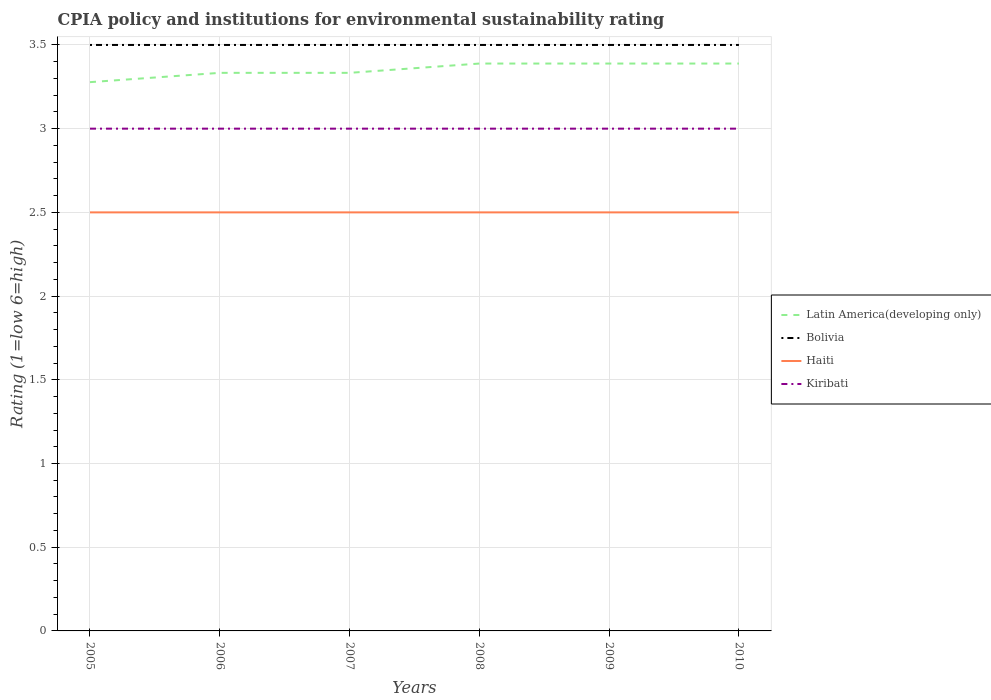Is the number of lines equal to the number of legend labels?
Keep it short and to the point. Yes. Across all years, what is the maximum CPIA rating in Latin America(developing only)?
Offer a terse response. 3.28. What is the total CPIA rating in Bolivia in the graph?
Keep it short and to the point. 0. What is the difference between the highest and the second highest CPIA rating in Latin America(developing only)?
Your answer should be very brief. 0.11. What is the difference between the highest and the lowest CPIA rating in Haiti?
Your answer should be very brief. 0. What is the difference between two consecutive major ticks on the Y-axis?
Offer a terse response. 0.5. Does the graph contain any zero values?
Give a very brief answer. No. Does the graph contain grids?
Ensure brevity in your answer.  Yes. How many legend labels are there?
Make the answer very short. 4. How are the legend labels stacked?
Give a very brief answer. Vertical. What is the title of the graph?
Ensure brevity in your answer.  CPIA policy and institutions for environmental sustainability rating. Does "Liberia" appear as one of the legend labels in the graph?
Offer a terse response. No. What is the label or title of the Y-axis?
Ensure brevity in your answer.  Rating (1=low 6=high). What is the Rating (1=low 6=high) of Latin America(developing only) in 2005?
Make the answer very short. 3.28. What is the Rating (1=low 6=high) of Latin America(developing only) in 2006?
Offer a terse response. 3.33. What is the Rating (1=low 6=high) of Latin America(developing only) in 2007?
Offer a terse response. 3.33. What is the Rating (1=low 6=high) in Haiti in 2007?
Offer a terse response. 2.5. What is the Rating (1=low 6=high) in Kiribati in 2007?
Make the answer very short. 3. What is the Rating (1=low 6=high) in Latin America(developing only) in 2008?
Ensure brevity in your answer.  3.39. What is the Rating (1=low 6=high) of Bolivia in 2008?
Your answer should be very brief. 3.5. What is the Rating (1=low 6=high) in Haiti in 2008?
Your answer should be very brief. 2.5. What is the Rating (1=low 6=high) in Kiribati in 2008?
Keep it short and to the point. 3. What is the Rating (1=low 6=high) of Latin America(developing only) in 2009?
Keep it short and to the point. 3.39. What is the Rating (1=low 6=high) in Latin America(developing only) in 2010?
Make the answer very short. 3.39. What is the Rating (1=low 6=high) of Bolivia in 2010?
Provide a short and direct response. 3.5. What is the Rating (1=low 6=high) of Haiti in 2010?
Give a very brief answer. 2.5. What is the Rating (1=low 6=high) in Kiribati in 2010?
Provide a short and direct response. 3. Across all years, what is the maximum Rating (1=low 6=high) of Latin America(developing only)?
Your answer should be compact. 3.39. Across all years, what is the maximum Rating (1=low 6=high) in Haiti?
Provide a succinct answer. 2.5. Across all years, what is the maximum Rating (1=low 6=high) in Kiribati?
Give a very brief answer. 3. Across all years, what is the minimum Rating (1=low 6=high) of Latin America(developing only)?
Your answer should be very brief. 3.28. What is the total Rating (1=low 6=high) in Latin America(developing only) in the graph?
Your answer should be very brief. 20.11. What is the total Rating (1=low 6=high) of Bolivia in the graph?
Offer a terse response. 21. What is the difference between the Rating (1=low 6=high) in Latin America(developing only) in 2005 and that in 2006?
Make the answer very short. -0.06. What is the difference between the Rating (1=low 6=high) in Bolivia in 2005 and that in 2006?
Provide a succinct answer. 0. What is the difference between the Rating (1=low 6=high) of Haiti in 2005 and that in 2006?
Make the answer very short. 0. What is the difference between the Rating (1=low 6=high) of Kiribati in 2005 and that in 2006?
Keep it short and to the point. 0. What is the difference between the Rating (1=low 6=high) of Latin America(developing only) in 2005 and that in 2007?
Make the answer very short. -0.06. What is the difference between the Rating (1=low 6=high) of Bolivia in 2005 and that in 2007?
Give a very brief answer. 0. What is the difference between the Rating (1=low 6=high) in Latin America(developing only) in 2005 and that in 2008?
Your answer should be very brief. -0.11. What is the difference between the Rating (1=low 6=high) of Bolivia in 2005 and that in 2008?
Provide a succinct answer. 0. What is the difference between the Rating (1=low 6=high) in Haiti in 2005 and that in 2008?
Offer a very short reply. 0. What is the difference between the Rating (1=low 6=high) of Latin America(developing only) in 2005 and that in 2009?
Your answer should be very brief. -0.11. What is the difference between the Rating (1=low 6=high) of Bolivia in 2005 and that in 2009?
Your response must be concise. 0. What is the difference between the Rating (1=low 6=high) of Kiribati in 2005 and that in 2009?
Provide a succinct answer. 0. What is the difference between the Rating (1=low 6=high) of Latin America(developing only) in 2005 and that in 2010?
Your answer should be compact. -0.11. What is the difference between the Rating (1=low 6=high) in Bolivia in 2005 and that in 2010?
Provide a short and direct response. 0. What is the difference between the Rating (1=low 6=high) of Kiribati in 2005 and that in 2010?
Give a very brief answer. 0. What is the difference between the Rating (1=low 6=high) in Latin America(developing only) in 2006 and that in 2007?
Make the answer very short. 0. What is the difference between the Rating (1=low 6=high) in Bolivia in 2006 and that in 2007?
Keep it short and to the point. 0. What is the difference between the Rating (1=low 6=high) of Haiti in 2006 and that in 2007?
Provide a succinct answer. 0. What is the difference between the Rating (1=low 6=high) of Kiribati in 2006 and that in 2007?
Make the answer very short. 0. What is the difference between the Rating (1=low 6=high) of Latin America(developing only) in 2006 and that in 2008?
Offer a terse response. -0.06. What is the difference between the Rating (1=low 6=high) in Latin America(developing only) in 2006 and that in 2009?
Provide a succinct answer. -0.06. What is the difference between the Rating (1=low 6=high) in Haiti in 2006 and that in 2009?
Your response must be concise. 0. What is the difference between the Rating (1=low 6=high) in Latin America(developing only) in 2006 and that in 2010?
Ensure brevity in your answer.  -0.06. What is the difference between the Rating (1=low 6=high) in Kiribati in 2006 and that in 2010?
Keep it short and to the point. 0. What is the difference between the Rating (1=low 6=high) in Latin America(developing only) in 2007 and that in 2008?
Your response must be concise. -0.06. What is the difference between the Rating (1=low 6=high) in Bolivia in 2007 and that in 2008?
Ensure brevity in your answer.  0. What is the difference between the Rating (1=low 6=high) in Haiti in 2007 and that in 2008?
Your answer should be compact. 0. What is the difference between the Rating (1=low 6=high) of Kiribati in 2007 and that in 2008?
Offer a very short reply. 0. What is the difference between the Rating (1=low 6=high) in Latin America(developing only) in 2007 and that in 2009?
Make the answer very short. -0.06. What is the difference between the Rating (1=low 6=high) in Latin America(developing only) in 2007 and that in 2010?
Provide a succinct answer. -0.06. What is the difference between the Rating (1=low 6=high) in Bolivia in 2007 and that in 2010?
Your answer should be compact. 0. What is the difference between the Rating (1=low 6=high) in Kiribati in 2007 and that in 2010?
Provide a short and direct response. 0. What is the difference between the Rating (1=low 6=high) in Bolivia in 2008 and that in 2009?
Offer a very short reply. 0. What is the difference between the Rating (1=low 6=high) in Haiti in 2008 and that in 2009?
Ensure brevity in your answer.  0. What is the difference between the Rating (1=low 6=high) of Latin America(developing only) in 2008 and that in 2010?
Your response must be concise. 0. What is the difference between the Rating (1=low 6=high) of Latin America(developing only) in 2009 and that in 2010?
Offer a terse response. 0. What is the difference between the Rating (1=low 6=high) of Bolivia in 2009 and that in 2010?
Offer a terse response. 0. What is the difference between the Rating (1=low 6=high) of Kiribati in 2009 and that in 2010?
Provide a succinct answer. 0. What is the difference between the Rating (1=low 6=high) of Latin America(developing only) in 2005 and the Rating (1=low 6=high) of Bolivia in 2006?
Offer a terse response. -0.22. What is the difference between the Rating (1=low 6=high) of Latin America(developing only) in 2005 and the Rating (1=low 6=high) of Haiti in 2006?
Your answer should be very brief. 0.78. What is the difference between the Rating (1=low 6=high) in Latin America(developing only) in 2005 and the Rating (1=low 6=high) in Kiribati in 2006?
Offer a very short reply. 0.28. What is the difference between the Rating (1=low 6=high) in Bolivia in 2005 and the Rating (1=low 6=high) in Haiti in 2006?
Give a very brief answer. 1. What is the difference between the Rating (1=low 6=high) in Latin America(developing only) in 2005 and the Rating (1=low 6=high) in Bolivia in 2007?
Your answer should be very brief. -0.22. What is the difference between the Rating (1=low 6=high) of Latin America(developing only) in 2005 and the Rating (1=low 6=high) of Haiti in 2007?
Offer a terse response. 0.78. What is the difference between the Rating (1=low 6=high) of Latin America(developing only) in 2005 and the Rating (1=low 6=high) of Kiribati in 2007?
Your answer should be very brief. 0.28. What is the difference between the Rating (1=low 6=high) in Bolivia in 2005 and the Rating (1=low 6=high) in Kiribati in 2007?
Provide a short and direct response. 0.5. What is the difference between the Rating (1=low 6=high) in Latin America(developing only) in 2005 and the Rating (1=low 6=high) in Bolivia in 2008?
Provide a succinct answer. -0.22. What is the difference between the Rating (1=low 6=high) in Latin America(developing only) in 2005 and the Rating (1=low 6=high) in Kiribati in 2008?
Keep it short and to the point. 0.28. What is the difference between the Rating (1=low 6=high) of Latin America(developing only) in 2005 and the Rating (1=low 6=high) of Bolivia in 2009?
Ensure brevity in your answer.  -0.22. What is the difference between the Rating (1=low 6=high) of Latin America(developing only) in 2005 and the Rating (1=low 6=high) of Kiribati in 2009?
Keep it short and to the point. 0.28. What is the difference between the Rating (1=low 6=high) in Bolivia in 2005 and the Rating (1=low 6=high) in Kiribati in 2009?
Make the answer very short. 0.5. What is the difference between the Rating (1=low 6=high) of Haiti in 2005 and the Rating (1=low 6=high) of Kiribati in 2009?
Your answer should be very brief. -0.5. What is the difference between the Rating (1=low 6=high) of Latin America(developing only) in 2005 and the Rating (1=low 6=high) of Bolivia in 2010?
Your answer should be very brief. -0.22. What is the difference between the Rating (1=low 6=high) in Latin America(developing only) in 2005 and the Rating (1=low 6=high) in Haiti in 2010?
Your response must be concise. 0.78. What is the difference between the Rating (1=low 6=high) in Latin America(developing only) in 2005 and the Rating (1=low 6=high) in Kiribati in 2010?
Offer a very short reply. 0.28. What is the difference between the Rating (1=low 6=high) in Bolivia in 2005 and the Rating (1=low 6=high) in Kiribati in 2010?
Make the answer very short. 0.5. What is the difference between the Rating (1=low 6=high) of Haiti in 2005 and the Rating (1=low 6=high) of Kiribati in 2010?
Your response must be concise. -0.5. What is the difference between the Rating (1=low 6=high) of Latin America(developing only) in 2006 and the Rating (1=low 6=high) of Bolivia in 2007?
Offer a very short reply. -0.17. What is the difference between the Rating (1=low 6=high) in Latin America(developing only) in 2006 and the Rating (1=low 6=high) in Bolivia in 2008?
Your answer should be compact. -0.17. What is the difference between the Rating (1=low 6=high) of Latin America(developing only) in 2006 and the Rating (1=low 6=high) of Haiti in 2008?
Provide a short and direct response. 0.83. What is the difference between the Rating (1=low 6=high) of Bolivia in 2006 and the Rating (1=low 6=high) of Kiribati in 2008?
Keep it short and to the point. 0.5. What is the difference between the Rating (1=low 6=high) in Latin America(developing only) in 2006 and the Rating (1=low 6=high) in Haiti in 2009?
Your answer should be compact. 0.83. What is the difference between the Rating (1=low 6=high) in Latin America(developing only) in 2006 and the Rating (1=low 6=high) in Kiribati in 2010?
Give a very brief answer. 0.33. What is the difference between the Rating (1=low 6=high) of Haiti in 2006 and the Rating (1=low 6=high) of Kiribati in 2010?
Your response must be concise. -0.5. What is the difference between the Rating (1=low 6=high) in Latin America(developing only) in 2007 and the Rating (1=low 6=high) in Bolivia in 2008?
Keep it short and to the point. -0.17. What is the difference between the Rating (1=low 6=high) in Latin America(developing only) in 2007 and the Rating (1=low 6=high) in Kiribati in 2008?
Offer a terse response. 0.33. What is the difference between the Rating (1=low 6=high) in Bolivia in 2007 and the Rating (1=low 6=high) in Haiti in 2008?
Provide a succinct answer. 1. What is the difference between the Rating (1=low 6=high) of Haiti in 2007 and the Rating (1=low 6=high) of Kiribati in 2008?
Offer a very short reply. -0.5. What is the difference between the Rating (1=low 6=high) in Latin America(developing only) in 2007 and the Rating (1=low 6=high) in Haiti in 2009?
Offer a very short reply. 0.83. What is the difference between the Rating (1=low 6=high) in Bolivia in 2007 and the Rating (1=low 6=high) in Kiribati in 2009?
Offer a terse response. 0.5. What is the difference between the Rating (1=low 6=high) in Haiti in 2007 and the Rating (1=low 6=high) in Kiribati in 2009?
Offer a very short reply. -0.5. What is the difference between the Rating (1=low 6=high) in Latin America(developing only) in 2007 and the Rating (1=low 6=high) in Bolivia in 2010?
Provide a short and direct response. -0.17. What is the difference between the Rating (1=low 6=high) in Bolivia in 2007 and the Rating (1=low 6=high) in Kiribati in 2010?
Your answer should be compact. 0.5. What is the difference between the Rating (1=low 6=high) of Latin America(developing only) in 2008 and the Rating (1=low 6=high) of Bolivia in 2009?
Your answer should be compact. -0.11. What is the difference between the Rating (1=low 6=high) in Latin America(developing only) in 2008 and the Rating (1=low 6=high) in Kiribati in 2009?
Give a very brief answer. 0.39. What is the difference between the Rating (1=low 6=high) of Haiti in 2008 and the Rating (1=low 6=high) of Kiribati in 2009?
Offer a terse response. -0.5. What is the difference between the Rating (1=low 6=high) of Latin America(developing only) in 2008 and the Rating (1=low 6=high) of Bolivia in 2010?
Offer a very short reply. -0.11. What is the difference between the Rating (1=low 6=high) in Latin America(developing only) in 2008 and the Rating (1=low 6=high) in Haiti in 2010?
Give a very brief answer. 0.89. What is the difference between the Rating (1=low 6=high) of Latin America(developing only) in 2008 and the Rating (1=low 6=high) of Kiribati in 2010?
Keep it short and to the point. 0.39. What is the difference between the Rating (1=low 6=high) in Latin America(developing only) in 2009 and the Rating (1=low 6=high) in Bolivia in 2010?
Keep it short and to the point. -0.11. What is the difference between the Rating (1=low 6=high) of Latin America(developing only) in 2009 and the Rating (1=low 6=high) of Kiribati in 2010?
Your answer should be very brief. 0.39. What is the difference between the Rating (1=low 6=high) of Bolivia in 2009 and the Rating (1=low 6=high) of Kiribati in 2010?
Make the answer very short. 0.5. What is the difference between the Rating (1=low 6=high) of Haiti in 2009 and the Rating (1=low 6=high) of Kiribati in 2010?
Make the answer very short. -0.5. What is the average Rating (1=low 6=high) in Latin America(developing only) per year?
Offer a terse response. 3.35. What is the average Rating (1=low 6=high) in Haiti per year?
Keep it short and to the point. 2.5. In the year 2005, what is the difference between the Rating (1=low 6=high) of Latin America(developing only) and Rating (1=low 6=high) of Bolivia?
Ensure brevity in your answer.  -0.22. In the year 2005, what is the difference between the Rating (1=low 6=high) of Latin America(developing only) and Rating (1=low 6=high) of Kiribati?
Make the answer very short. 0.28. In the year 2005, what is the difference between the Rating (1=low 6=high) in Bolivia and Rating (1=low 6=high) in Kiribati?
Your answer should be very brief. 0.5. In the year 2006, what is the difference between the Rating (1=low 6=high) of Latin America(developing only) and Rating (1=low 6=high) of Bolivia?
Ensure brevity in your answer.  -0.17. In the year 2006, what is the difference between the Rating (1=low 6=high) of Haiti and Rating (1=low 6=high) of Kiribati?
Your response must be concise. -0.5. In the year 2007, what is the difference between the Rating (1=low 6=high) in Latin America(developing only) and Rating (1=low 6=high) in Bolivia?
Your answer should be compact. -0.17. In the year 2007, what is the difference between the Rating (1=low 6=high) of Latin America(developing only) and Rating (1=low 6=high) of Haiti?
Your answer should be compact. 0.83. In the year 2007, what is the difference between the Rating (1=low 6=high) of Latin America(developing only) and Rating (1=low 6=high) of Kiribati?
Offer a very short reply. 0.33. In the year 2007, what is the difference between the Rating (1=low 6=high) of Bolivia and Rating (1=low 6=high) of Haiti?
Offer a very short reply. 1. In the year 2007, what is the difference between the Rating (1=low 6=high) in Bolivia and Rating (1=low 6=high) in Kiribati?
Give a very brief answer. 0.5. In the year 2007, what is the difference between the Rating (1=low 6=high) in Haiti and Rating (1=low 6=high) in Kiribati?
Your response must be concise. -0.5. In the year 2008, what is the difference between the Rating (1=low 6=high) in Latin America(developing only) and Rating (1=low 6=high) in Bolivia?
Your response must be concise. -0.11. In the year 2008, what is the difference between the Rating (1=low 6=high) in Latin America(developing only) and Rating (1=low 6=high) in Haiti?
Make the answer very short. 0.89. In the year 2008, what is the difference between the Rating (1=low 6=high) in Latin America(developing only) and Rating (1=low 6=high) in Kiribati?
Provide a short and direct response. 0.39. In the year 2008, what is the difference between the Rating (1=low 6=high) of Bolivia and Rating (1=low 6=high) of Kiribati?
Give a very brief answer. 0.5. In the year 2008, what is the difference between the Rating (1=low 6=high) in Haiti and Rating (1=low 6=high) in Kiribati?
Your response must be concise. -0.5. In the year 2009, what is the difference between the Rating (1=low 6=high) of Latin America(developing only) and Rating (1=low 6=high) of Bolivia?
Ensure brevity in your answer.  -0.11. In the year 2009, what is the difference between the Rating (1=low 6=high) in Latin America(developing only) and Rating (1=low 6=high) in Kiribati?
Provide a succinct answer. 0.39. In the year 2009, what is the difference between the Rating (1=low 6=high) in Bolivia and Rating (1=low 6=high) in Haiti?
Give a very brief answer. 1. In the year 2009, what is the difference between the Rating (1=low 6=high) in Bolivia and Rating (1=low 6=high) in Kiribati?
Your response must be concise. 0.5. In the year 2009, what is the difference between the Rating (1=low 6=high) of Haiti and Rating (1=low 6=high) of Kiribati?
Give a very brief answer. -0.5. In the year 2010, what is the difference between the Rating (1=low 6=high) of Latin America(developing only) and Rating (1=low 6=high) of Bolivia?
Ensure brevity in your answer.  -0.11. In the year 2010, what is the difference between the Rating (1=low 6=high) of Latin America(developing only) and Rating (1=low 6=high) of Kiribati?
Offer a very short reply. 0.39. In the year 2010, what is the difference between the Rating (1=low 6=high) in Bolivia and Rating (1=low 6=high) in Kiribati?
Offer a very short reply. 0.5. What is the ratio of the Rating (1=low 6=high) of Latin America(developing only) in 2005 to that in 2006?
Your answer should be compact. 0.98. What is the ratio of the Rating (1=low 6=high) of Haiti in 2005 to that in 2006?
Make the answer very short. 1. What is the ratio of the Rating (1=low 6=high) in Latin America(developing only) in 2005 to that in 2007?
Your answer should be compact. 0.98. What is the ratio of the Rating (1=low 6=high) in Haiti in 2005 to that in 2007?
Provide a succinct answer. 1. What is the ratio of the Rating (1=low 6=high) in Kiribati in 2005 to that in 2007?
Keep it short and to the point. 1. What is the ratio of the Rating (1=low 6=high) of Latin America(developing only) in 2005 to that in 2008?
Ensure brevity in your answer.  0.97. What is the ratio of the Rating (1=low 6=high) in Bolivia in 2005 to that in 2008?
Your answer should be very brief. 1. What is the ratio of the Rating (1=low 6=high) of Kiribati in 2005 to that in 2008?
Your answer should be very brief. 1. What is the ratio of the Rating (1=low 6=high) of Latin America(developing only) in 2005 to that in 2009?
Ensure brevity in your answer.  0.97. What is the ratio of the Rating (1=low 6=high) in Bolivia in 2005 to that in 2009?
Your answer should be very brief. 1. What is the ratio of the Rating (1=low 6=high) in Haiti in 2005 to that in 2009?
Your answer should be very brief. 1. What is the ratio of the Rating (1=low 6=high) in Latin America(developing only) in 2005 to that in 2010?
Offer a terse response. 0.97. What is the ratio of the Rating (1=low 6=high) in Kiribati in 2005 to that in 2010?
Offer a very short reply. 1. What is the ratio of the Rating (1=low 6=high) of Haiti in 2006 to that in 2007?
Offer a terse response. 1. What is the ratio of the Rating (1=low 6=high) in Kiribati in 2006 to that in 2007?
Provide a short and direct response. 1. What is the ratio of the Rating (1=low 6=high) of Latin America(developing only) in 2006 to that in 2008?
Ensure brevity in your answer.  0.98. What is the ratio of the Rating (1=low 6=high) of Bolivia in 2006 to that in 2008?
Provide a succinct answer. 1. What is the ratio of the Rating (1=low 6=high) of Latin America(developing only) in 2006 to that in 2009?
Provide a succinct answer. 0.98. What is the ratio of the Rating (1=low 6=high) of Bolivia in 2006 to that in 2009?
Provide a short and direct response. 1. What is the ratio of the Rating (1=low 6=high) in Haiti in 2006 to that in 2009?
Offer a terse response. 1. What is the ratio of the Rating (1=low 6=high) of Kiribati in 2006 to that in 2009?
Provide a succinct answer. 1. What is the ratio of the Rating (1=low 6=high) in Latin America(developing only) in 2006 to that in 2010?
Offer a very short reply. 0.98. What is the ratio of the Rating (1=low 6=high) in Bolivia in 2006 to that in 2010?
Give a very brief answer. 1. What is the ratio of the Rating (1=low 6=high) of Haiti in 2006 to that in 2010?
Offer a very short reply. 1. What is the ratio of the Rating (1=low 6=high) of Latin America(developing only) in 2007 to that in 2008?
Offer a very short reply. 0.98. What is the ratio of the Rating (1=low 6=high) in Bolivia in 2007 to that in 2008?
Ensure brevity in your answer.  1. What is the ratio of the Rating (1=low 6=high) in Latin America(developing only) in 2007 to that in 2009?
Keep it short and to the point. 0.98. What is the ratio of the Rating (1=low 6=high) in Bolivia in 2007 to that in 2009?
Make the answer very short. 1. What is the ratio of the Rating (1=low 6=high) in Haiti in 2007 to that in 2009?
Make the answer very short. 1. What is the ratio of the Rating (1=low 6=high) in Kiribati in 2007 to that in 2009?
Give a very brief answer. 1. What is the ratio of the Rating (1=low 6=high) in Latin America(developing only) in 2007 to that in 2010?
Your answer should be compact. 0.98. What is the ratio of the Rating (1=low 6=high) of Kiribati in 2007 to that in 2010?
Keep it short and to the point. 1. What is the ratio of the Rating (1=low 6=high) in Latin America(developing only) in 2008 to that in 2009?
Offer a very short reply. 1. What is the ratio of the Rating (1=low 6=high) in Bolivia in 2008 to that in 2009?
Offer a terse response. 1. What is the ratio of the Rating (1=low 6=high) of Haiti in 2008 to that in 2009?
Your answer should be compact. 1. What is the ratio of the Rating (1=low 6=high) in Latin America(developing only) in 2009 to that in 2010?
Your answer should be very brief. 1. What is the ratio of the Rating (1=low 6=high) in Bolivia in 2009 to that in 2010?
Offer a very short reply. 1. What is the difference between the highest and the second highest Rating (1=low 6=high) in Latin America(developing only)?
Your response must be concise. 0. What is the difference between the highest and the lowest Rating (1=low 6=high) of Haiti?
Ensure brevity in your answer.  0. What is the difference between the highest and the lowest Rating (1=low 6=high) in Kiribati?
Provide a short and direct response. 0. 